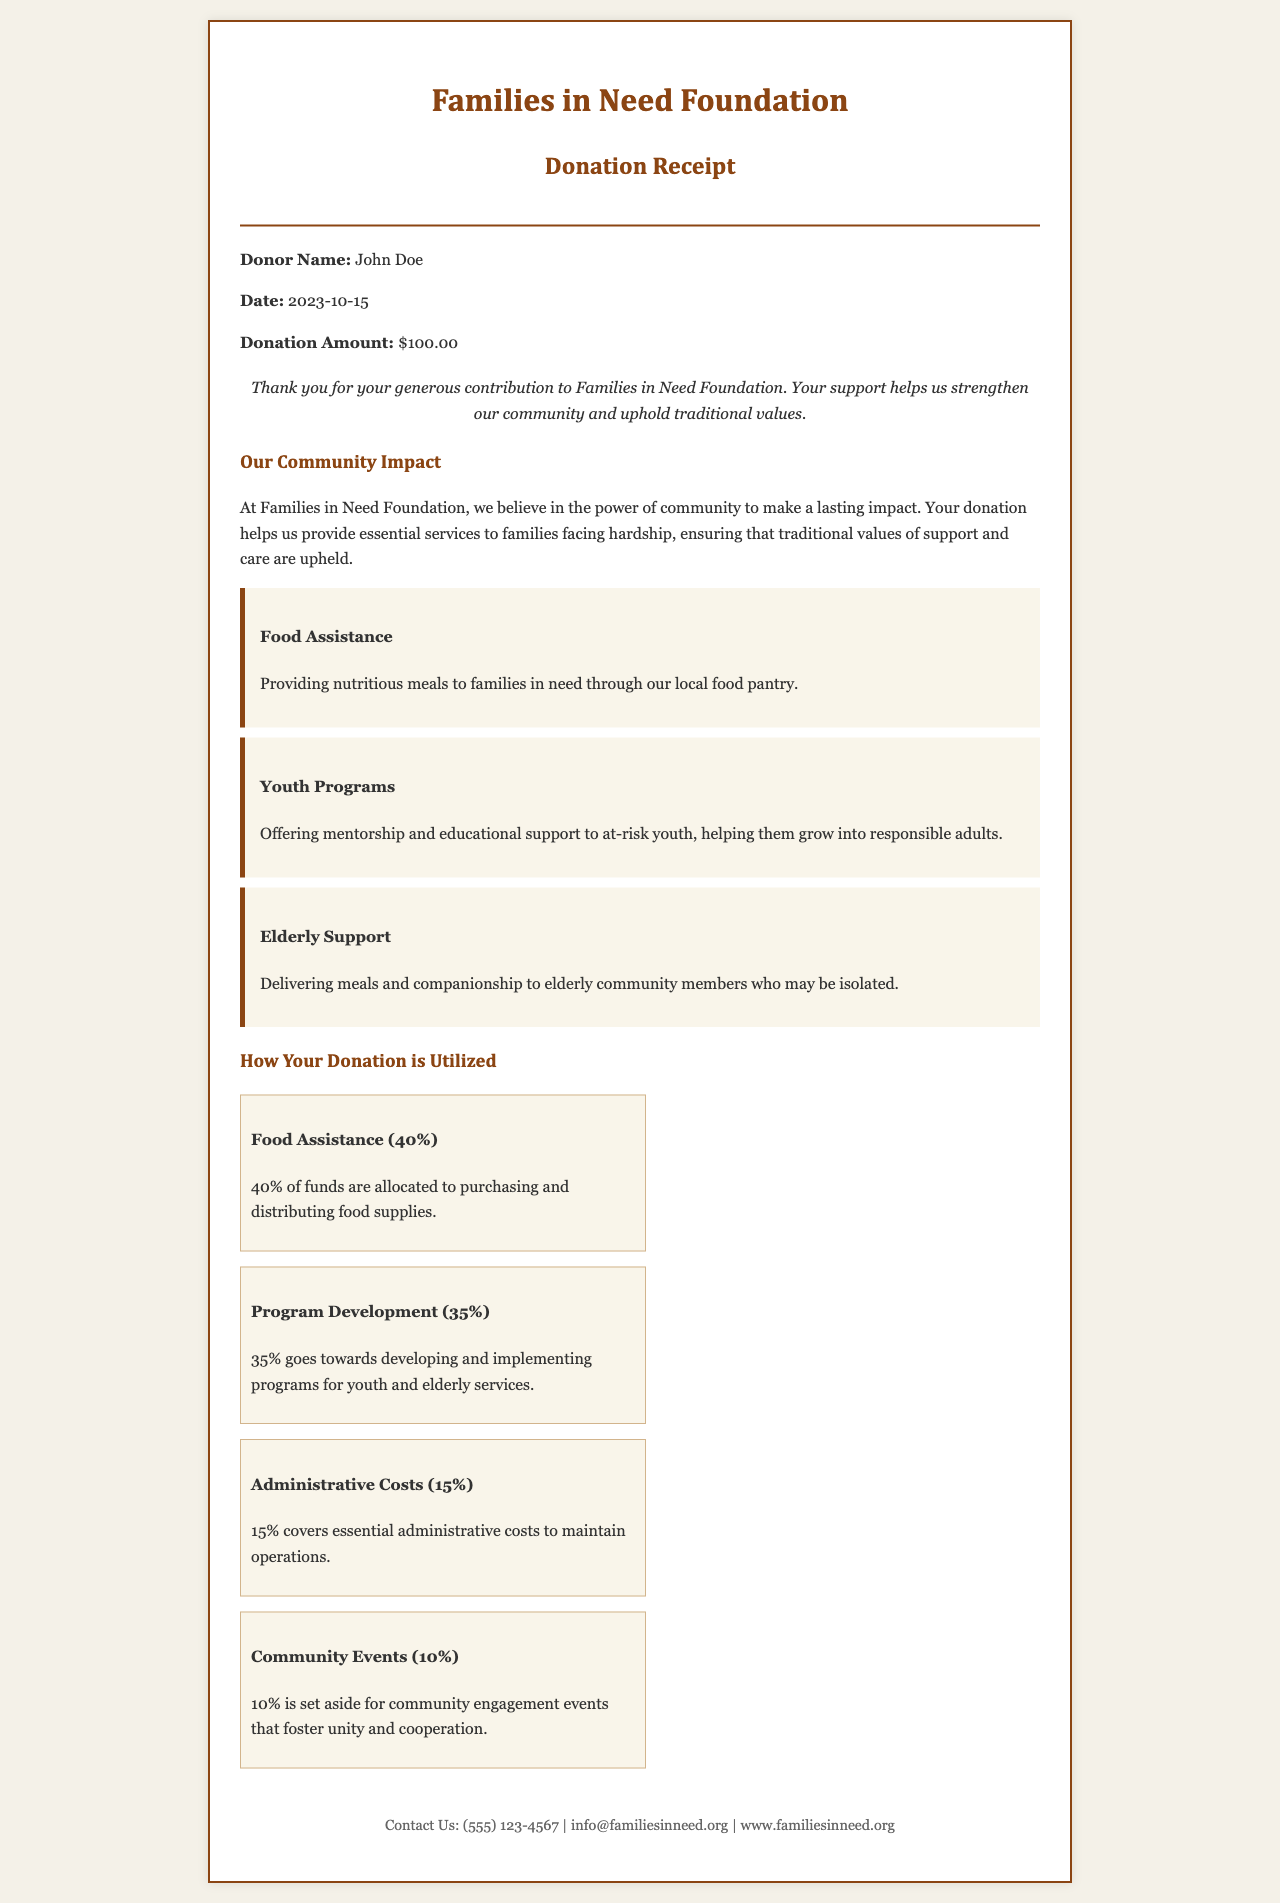What is the name of the organization? The organization's name is stated at the top of the document as Families in Need Foundation.
Answer: Families in Need Foundation What is the donation amount? The donation amount is explicitly mentioned in the receipt as $100.00.
Answer: $100.00 What percentage of funds is allocated to food assistance? The funds allocated to food assistance is detailed in the breakdown, which shows 40% dedicated to this area.
Answer: 40% When was the donation made? The date of the donation is provided in the document, which indicates it was made on 2023-10-15.
Answer: 2023-10-15 What services are provided to elderly community members? The document mentions delivering meals and companionship to elderly community members.
Answer: Delivering meals and companionship How much of the donation goes to administrative costs? The percentage for administrative costs is specified in the document as 15%.
Answer: 15% What type of programs are offered for at-risk youth? The receipt describes mentorship and educational support programs for at-risk youth.
Answer: Mentorship and educational support What contact information is provided in the document? The receipt includes a phone number and email address for contact: (555) 123-4567
Answer: (555) 123-4567 What is the purpose of community events according to the document? The purpose of community events is stated as fostering unity and cooperation.
Answer: Fostering unity and cooperation 